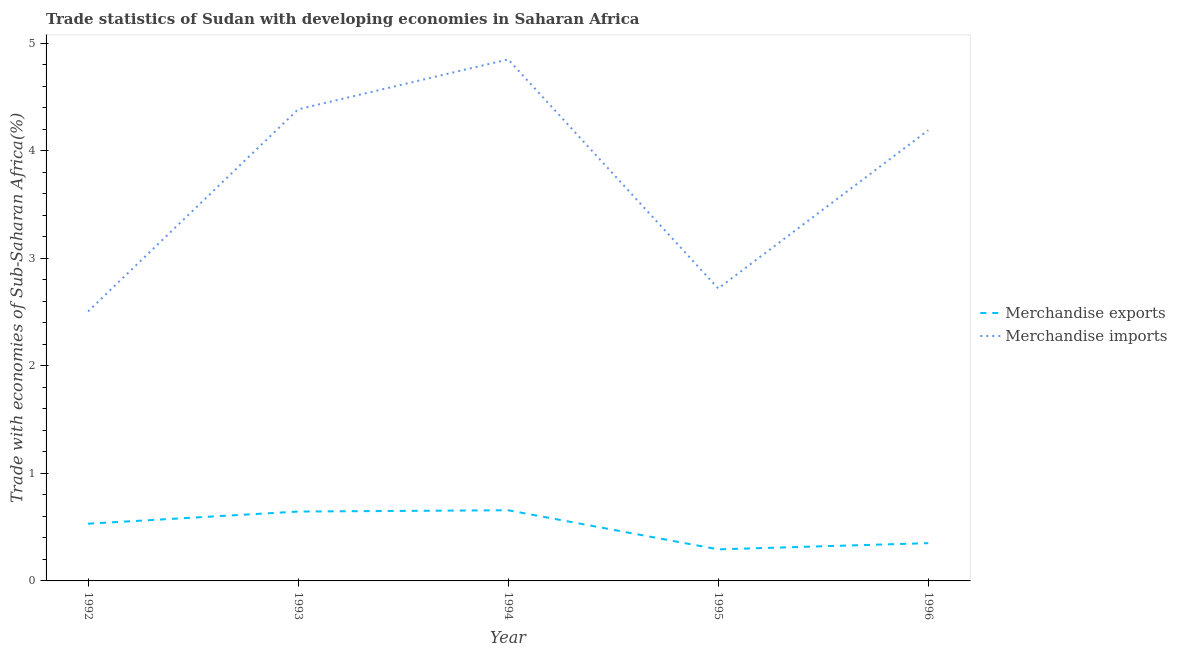What is the merchandise exports in 1993?
Make the answer very short. 0.65. Across all years, what is the maximum merchandise imports?
Provide a succinct answer. 4.85. Across all years, what is the minimum merchandise exports?
Make the answer very short. 0.29. In which year was the merchandise imports maximum?
Offer a very short reply. 1994. In which year was the merchandise imports minimum?
Your answer should be very brief. 1992. What is the total merchandise exports in the graph?
Offer a very short reply. 2.48. What is the difference between the merchandise exports in 1992 and that in 1993?
Make the answer very short. -0.11. What is the difference between the merchandise imports in 1992 and the merchandise exports in 1996?
Keep it short and to the point. 2.16. What is the average merchandise imports per year?
Ensure brevity in your answer.  3.73. In the year 1995, what is the difference between the merchandise imports and merchandise exports?
Your answer should be compact. 2.43. What is the ratio of the merchandise exports in 1992 to that in 1994?
Your response must be concise. 0.81. What is the difference between the highest and the second highest merchandise exports?
Make the answer very short. 0.01. What is the difference between the highest and the lowest merchandise exports?
Ensure brevity in your answer.  0.36. Is the sum of the merchandise imports in 1992 and 1995 greater than the maximum merchandise exports across all years?
Keep it short and to the point. Yes. Is the merchandise exports strictly less than the merchandise imports over the years?
Keep it short and to the point. Yes. How many lines are there?
Provide a short and direct response. 2. What is the difference between two consecutive major ticks on the Y-axis?
Your response must be concise. 1. Are the values on the major ticks of Y-axis written in scientific E-notation?
Give a very brief answer. No. Does the graph contain any zero values?
Ensure brevity in your answer.  No. Does the graph contain grids?
Provide a succinct answer. No. Where does the legend appear in the graph?
Your answer should be very brief. Center right. How many legend labels are there?
Provide a short and direct response. 2. What is the title of the graph?
Provide a succinct answer. Trade statistics of Sudan with developing economies in Saharan Africa. What is the label or title of the X-axis?
Make the answer very short. Year. What is the label or title of the Y-axis?
Make the answer very short. Trade with economies of Sub-Saharan Africa(%). What is the Trade with economies of Sub-Saharan Africa(%) in Merchandise exports in 1992?
Your answer should be compact. 0.53. What is the Trade with economies of Sub-Saharan Africa(%) of Merchandise imports in 1992?
Give a very brief answer. 2.51. What is the Trade with economies of Sub-Saharan Africa(%) in Merchandise exports in 1993?
Provide a short and direct response. 0.65. What is the Trade with economies of Sub-Saharan Africa(%) in Merchandise imports in 1993?
Provide a succinct answer. 4.39. What is the Trade with economies of Sub-Saharan Africa(%) in Merchandise exports in 1994?
Keep it short and to the point. 0.66. What is the Trade with economies of Sub-Saharan Africa(%) of Merchandise imports in 1994?
Make the answer very short. 4.85. What is the Trade with economies of Sub-Saharan Africa(%) in Merchandise exports in 1995?
Offer a terse response. 0.29. What is the Trade with economies of Sub-Saharan Africa(%) of Merchandise imports in 1995?
Your answer should be compact. 2.72. What is the Trade with economies of Sub-Saharan Africa(%) of Merchandise exports in 1996?
Provide a short and direct response. 0.35. What is the Trade with economies of Sub-Saharan Africa(%) of Merchandise imports in 1996?
Make the answer very short. 4.19. Across all years, what is the maximum Trade with economies of Sub-Saharan Africa(%) in Merchandise exports?
Keep it short and to the point. 0.66. Across all years, what is the maximum Trade with economies of Sub-Saharan Africa(%) in Merchandise imports?
Provide a short and direct response. 4.85. Across all years, what is the minimum Trade with economies of Sub-Saharan Africa(%) in Merchandise exports?
Offer a very short reply. 0.29. Across all years, what is the minimum Trade with economies of Sub-Saharan Africa(%) of Merchandise imports?
Your answer should be compact. 2.51. What is the total Trade with economies of Sub-Saharan Africa(%) of Merchandise exports in the graph?
Keep it short and to the point. 2.48. What is the total Trade with economies of Sub-Saharan Africa(%) in Merchandise imports in the graph?
Provide a short and direct response. 18.66. What is the difference between the Trade with economies of Sub-Saharan Africa(%) in Merchandise exports in 1992 and that in 1993?
Your answer should be compact. -0.11. What is the difference between the Trade with economies of Sub-Saharan Africa(%) of Merchandise imports in 1992 and that in 1993?
Make the answer very short. -1.88. What is the difference between the Trade with economies of Sub-Saharan Africa(%) of Merchandise exports in 1992 and that in 1994?
Keep it short and to the point. -0.13. What is the difference between the Trade with economies of Sub-Saharan Africa(%) in Merchandise imports in 1992 and that in 1994?
Give a very brief answer. -2.34. What is the difference between the Trade with economies of Sub-Saharan Africa(%) in Merchandise exports in 1992 and that in 1995?
Your response must be concise. 0.24. What is the difference between the Trade with economies of Sub-Saharan Africa(%) in Merchandise imports in 1992 and that in 1995?
Offer a very short reply. -0.21. What is the difference between the Trade with economies of Sub-Saharan Africa(%) in Merchandise exports in 1992 and that in 1996?
Provide a short and direct response. 0.18. What is the difference between the Trade with economies of Sub-Saharan Africa(%) in Merchandise imports in 1992 and that in 1996?
Ensure brevity in your answer.  -1.69. What is the difference between the Trade with economies of Sub-Saharan Africa(%) in Merchandise exports in 1993 and that in 1994?
Ensure brevity in your answer.  -0.01. What is the difference between the Trade with economies of Sub-Saharan Africa(%) of Merchandise imports in 1993 and that in 1994?
Give a very brief answer. -0.47. What is the difference between the Trade with economies of Sub-Saharan Africa(%) of Merchandise exports in 1993 and that in 1995?
Offer a very short reply. 0.35. What is the difference between the Trade with economies of Sub-Saharan Africa(%) of Merchandise imports in 1993 and that in 1995?
Your answer should be very brief. 1.67. What is the difference between the Trade with economies of Sub-Saharan Africa(%) in Merchandise exports in 1993 and that in 1996?
Offer a terse response. 0.29. What is the difference between the Trade with economies of Sub-Saharan Africa(%) of Merchandise imports in 1993 and that in 1996?
Your response must be concise. 0.19. What is the difference between the Trade with economies of Sub-Saharan Africa(%) of Merchandise exports in 1994 and that in 1995?
Offer a very short reply. 0.36. What is the difference between the Trade with economies of Sub-Saharan Africa(%) in Merchandise imports in 1994 and that in 1995?
Provide a succinct answer. 2.13. What is the difference between the Trade with economies of Sub-Saharan Africa(%) in Merchandise exports in 1994 and that in 1996?
Your response must be concise. 0.31. What is the difference between the Trade with economies of Sub-Saharan Africa(%) in Merchandise imports in 1994 and that in 1996?
Keep it short and to the point. 0.66. What is the difference between the Trade with economies of Sub-Saharan Africa(%) of Merchandise exports in 1995 and that in 1996?
Your response must be concise. -0.06. What is the difference between the Trade with economies of Sub-Saharan Africa(%) in Merchandise imports in 1995 and that in 1996?
Make the answer very short. -1.47. What is the difference between the Trade with economies of Sub-Saharan Africa(%) in Merchandise exports in 1992 and the Trade with economies of Sub-Saharan Africa(%) in Merchandise imports in 1993?
Your response must be concise. -3.85. What is the difference between the Trade with economies of Sub-Saharan Africa(%) in Merchandise exports in 1992 and the Trade with economies of Sub-Saharan Africa(%) in Merchandise imports in 1994?
Give a very brief answer. -4.32. What is the difference between the Trade with economies of Sub-Saharan Africa(%) in Merchandise exports in 1992 and the Trade with economies of Sub-Saharan Africa(%) in Merchandise imports in 1995?
Offer a terse response. -2.19. What is the difference between the Trade with economies of Sub-Saharan Africa(%) of Merchandise exports in 1992 and the Trade with economies of Sub-Saharan Africa(%) of Merchandise imports in 1996?
Your answer should be compact. -3.66. What is the difference between the Trade with economies of Sub-Saharan Africa(%) in Merchandise exports in 1993 and the Trade with economies of Sub-Saharan Africa(%) in Merchandise imports in 1994?
Offer a terse response. -4.21. What is the difference between the Trade with economies of Sub-Saharan Africa(%) in Merchandise exports in 1993 and the Trade with economies of Sub-Saharan Africa(%) in Merchandise imports in 1995?
Provide a succinct answer. -2.07. What is the difference between the Trade with economies of Sub-Saharan Africa(%) in Merchandise exports in 1993 and the Trade with economies of Sub-Saharan Africa(%) in Merchandise imports in 1996?
Provide a succinct answer. -3.55. What is the difference between the Trade with economies of Sub-Saharan Africa(%) in Merchandise exports in 1994 and the Trade with economies of Sub-Saharan Africa(%) in Merchandise imports in 1995?
Ensure brevity in your answer.  -2.06. What is the difference between the Trade with economies of Sub-Saharan Africa(%) in Merchandise exports in 1994 and the Trade with economies of Sub-Saharan Africa(%) in Merchandise imports in 1996?
Give a very brief answer. -3.53. What is the difference between the Trade with economies of Sub-Saharan Africa(%) of Merchandise exports in 1995 and the Trade with economies of Sub-Saharan Africa(%) of Merchandise imports in 1996?
Your answer should be very brief. -3.9. What is the average Trade with economies of Sub-Saharan Africa(%) in Merchandise exports per year?
Your answer should be very brief. 0.5. What is the average Trade with economies of Sub-Saharan Africa(%) in Merchandise imports per year?
Ensure brevity in your answer.  3.73. In the year 1992, what is the difference between the Trade with economies of Sub-Saharan Africa(%) in Merchandise exports and Trade with economies of Sub-Saharan Africa(%) in Merchandise imports?
Give a very brief answer. -1.97. In the year 1993, what is the difference between the Trade with economies of Sub-Saharan Africa(%) in Merchandise exports and Trade with economies of Sub-Saharan Africa(%) in Merchandise imports?
Keep it short and to the point. -3.74. In the year 1994, what is the difference between the Trade with economies of Sub-Saharan Africa(%) in Merchandise exports and Trade with economies of Sub-Saharan Africa(%) in Merchandise imports?
Provide a succinct answer. -4.19. In the year 1995, what is the difference between the Trade with economies of Sub-Saharan Africa(%) of Merchandise exports and Trade with economies of Sub-Saharan Africa(%) of Merchandise imports?
Your response must be concise. -2.43. In the year 1996, what is the difference between the Trade with economies of Sub-Saharan Africa(%) of Merchandise exports and Trade with economies of Sub-Saharan Africa(%) of Merchandise imports?
Your answer should be compact. -3.84. What is the ratio of the Trade with economies of Sub-Saharan Africa(%) of Merchandise exports in 1992 to that in 1993?
Keep it short and to the point. 0.82. What is the ratio of the Trade with economies of Sub-Saharan Africa(%) of Merchandise imports in 1992 to that in 1993?
Your answer should be compact. 0.57. What is the ratio of the Trade with economies of Sub-Saharan Africa(%) in Merchandise exports in 1992 to that in 1994?
Provide a short and direct response. 0.81. What is the ratio of the Trade with economies of Sub-Saharan Africa(%) in Merchandise imports in 1992 to that in 1994?
Your answer should be very brief. 0.52. What is the ratio of the Trade with economies of Sub-Saharan Africa(%) of Merchandise exports in 1992 to that in 1995?
Give a very brief answer. 1.81. What is the ratio of the Trade with economies of Sub-Saharan Africa(%) of Merchandise imports in 1992 to that in 1995?
Provide a succinct answer. 0.92. What is the ratio of the Trade with economies of Sub-Saharan Africa(%) in Merchandise exports in 1992 to that in 1996?
Make the answer very short. 1.51. What is the ratio of the Trade with economies of Sub-Saharan Africa(%) in Merchandise imports in 1992 to that in 1996?
Provide a short and direct response. 0.6. What is the ratio of the Trade with economies of Sub-Saharan Africa(%) of Merchandise exports in 1993 to that in 1994?
Offer a terse response. 0.98. What is the ratio of the Trade with economies of Sub-Saharan Africa(%) of Merchandise imports in 1993 to that in 1994?
Provide a short and direct response. 0.9. What is the ratio of the Trade with economies of Sub-Saharan Africa(%) in Merchandise exports in 1993 to that in 1995?
Provide a succinct answer. 2.2. What is the ratio of the Trade with economies of Sub-Saharan Africa(%) in Merchandise imports in 1993 to that in 1995?
Provide a succinct answer. 1.61. What is the ratio of the Trade with economies of Sub-Saharan Africa(%) in Merchandise exports in 1993 to that in 1996?
Your answer should be compact. 1.84. What is the ratio of the Trade with economies of Sub-Saharan Africa(%) in Merchandise imports in 1993 to that in 1996?
Make the answer very short. 1.05. What is the ratio of the Trade with economies of Sub-Saharan Africa(%) of Merchandise exports in 1994 to that in 1995?
Give a very brief answer. 2.24. What is the ratio of the Trade with economies of Sub-Saharan Africa(%) of Merchandise imports in 1994 to that in 1995?
Provide a short and direct response. 1.78. What is the ratio of the Trade with economies of Sub-Saharan Africa(%) in Merchandise exports in 1994 to that in 1996?
Give a very brief answer. 1.87. What is the ratio of the Trade with economies of Sub-Saharan Africa(%) of Merchandise imports in 1994 to that in 1996?
Ensure brevity in your answer.  1.16. What is the ratio of the Trade with economies of Sub-Saharan Africa(%) of Merchandise exports in 1995 to that in 1996?
Offer a very short reply. 0.84. What is the ratio of the Trade with economies of Sub-Saharan Africa(%) of Merchandise imports in 1995 to that in 1996?
Provide a succinct answer. 0.65. What is the difference between the highest and the second highest Trade with economies of Sub-Saharan Africa(%) of Merchandise exports?
Offer a terse response. 0.01. What is the difference between the highest and the second highest Trade with economies of Sub-Saharan Africa(%) in Merchandise imports?
Provide a succinct answer. 0.47. What is the difference between the highest and the lowest Trade with economies of Sub-Saharan Africa(%) in Merchandise exports?
Your answer should be compact. 0.36. What is the difference between the highest and the lowest Trade with economies of Sub-Saharan Africa(%) in Merchandise imports?
Your answer should be compact. 2.34. 